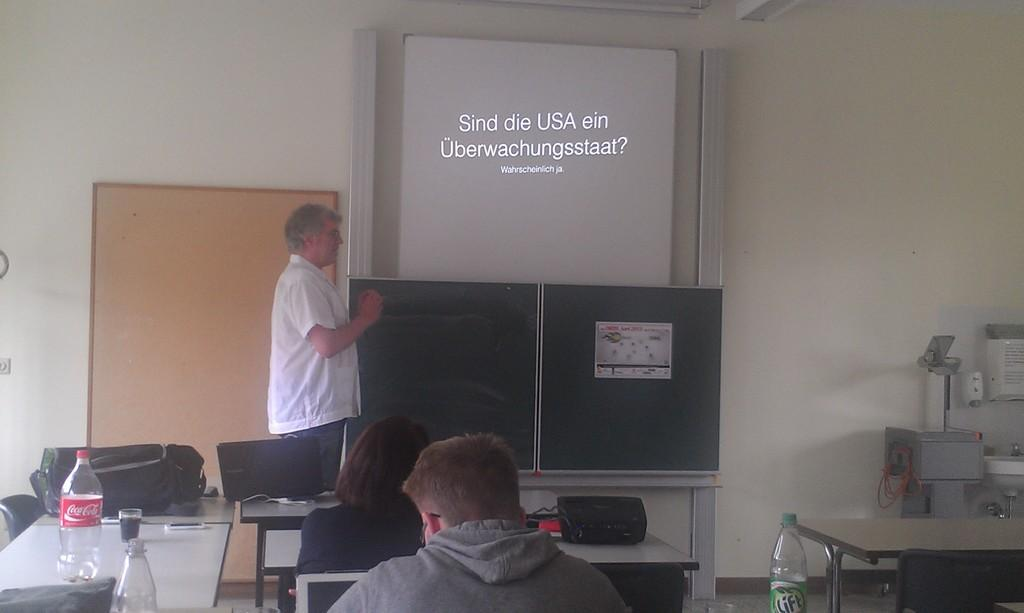How many people are sitting in the image? There are two persons sitting on chairs in the image. What is the position of the third person in the image? There is a person standing in the image. What can be seen in the background of the image? There is a wall, objects, and a board in the background of the image. What type of weather can be seen in the image? There is no information about the weather in the image. The image does not show any outdoor elements or weather conditions. 